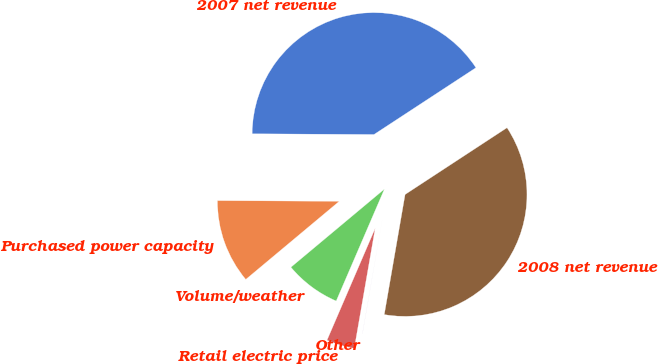<chart> <loc_0><loc_0><loc_500><loc_500><pie_chart><fcel>2007 net revenue<fcel>Purchased power capacity<fcel>Volume/weather<fcel>Retail electric price<fcel>Other<fcel>2008 net revenue<nl><fcel>40.69%<fcel>11.17%<fcel>7.45%<fcel>3.73%<fcel>0.01%<fcel>36.97%<nl></chart> 